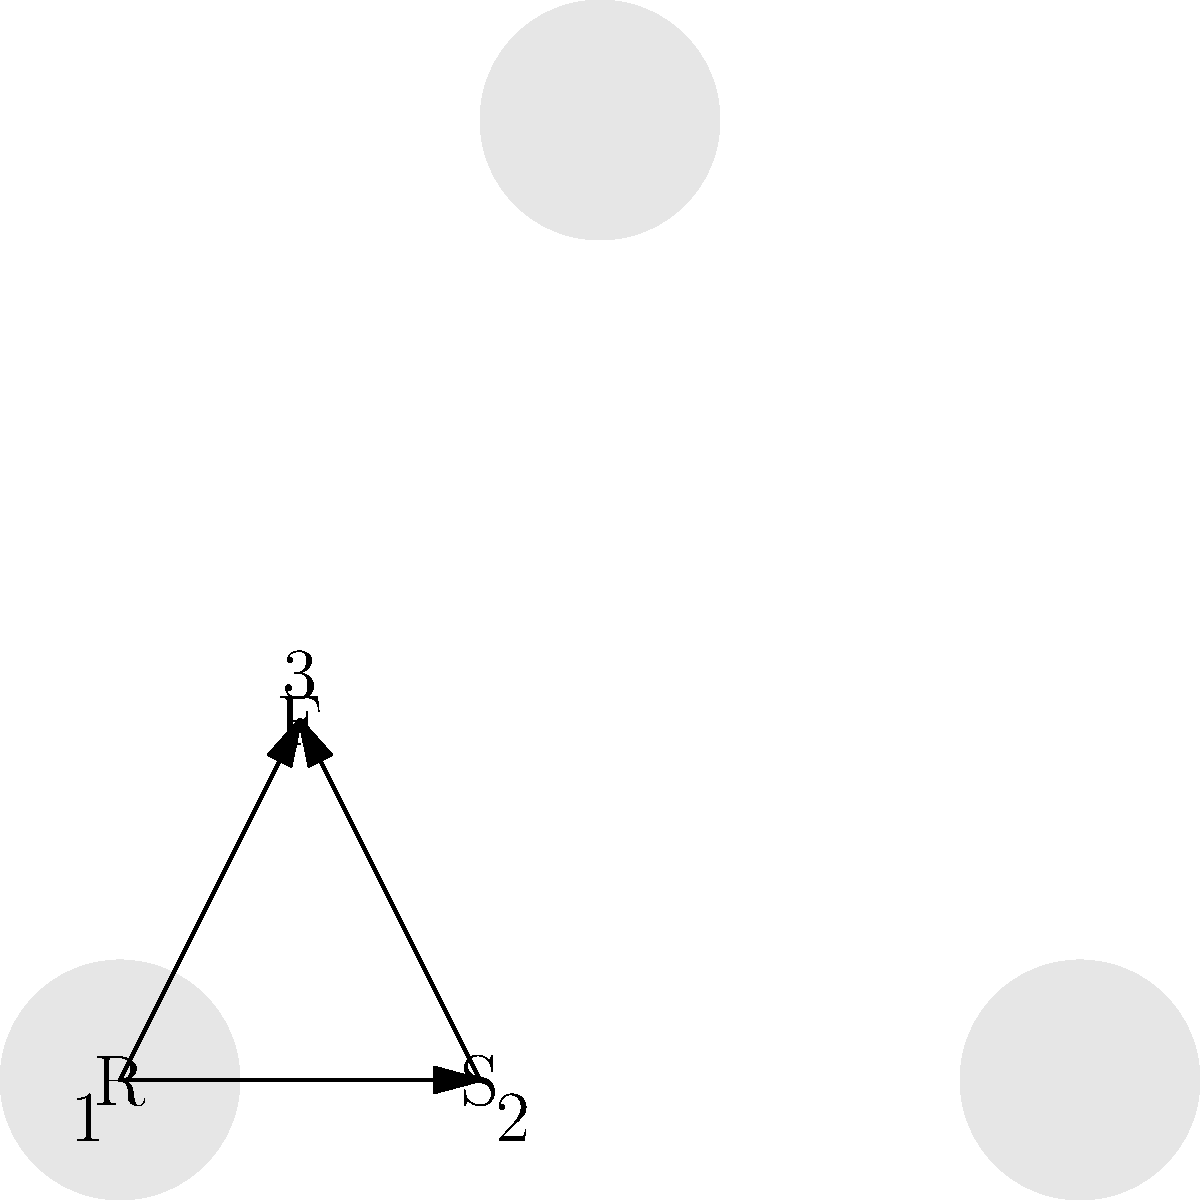In the network diagram above, identify the devices represented by the icons labeled 1, 2, and 3. Which device acts as a gateway between different networks? To identify the network devices and determine which acts as a gateway, let's analyze each icon:

1. Icon 1 (labeled "R"): This represents a Router. Routers are devices that forward data packets between computer networks, making them essential for internetwork communication.

2. Icon 2 (labeled "S"): This represents a Switch. Switches connect devices within the same network, allowing them to communicate with each other efficiently.

3. Icon 3 (labeled "F"): This represents a Firewall. Firewalls monitor and control incoming and outgoing network traffic based on predetermined security rules.

Among these devices, the Router (Icon 1) acts as a gateway between different networks. Routers are designed to:

- Connect multiple networks together
- Determine the best path for data to travel between networks
- Forward packets from one network to another

Switches operate within a single network, while firewalls primarily focus on security. Therefore, the Router is the device that functions as a gateway between different networks.
Answer: Router (Icon 1) 